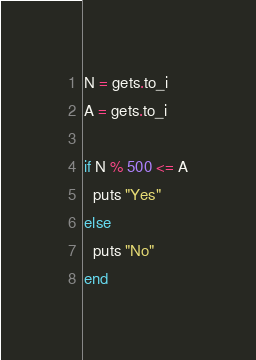<code> <loc_0><loc_0><loc_500><loc_500><_Ruby_>N = gets.to_i
A = gets.to_i

if N % 500 <= A
  puts "Yes"
else
  puts "No"
end
</code> 